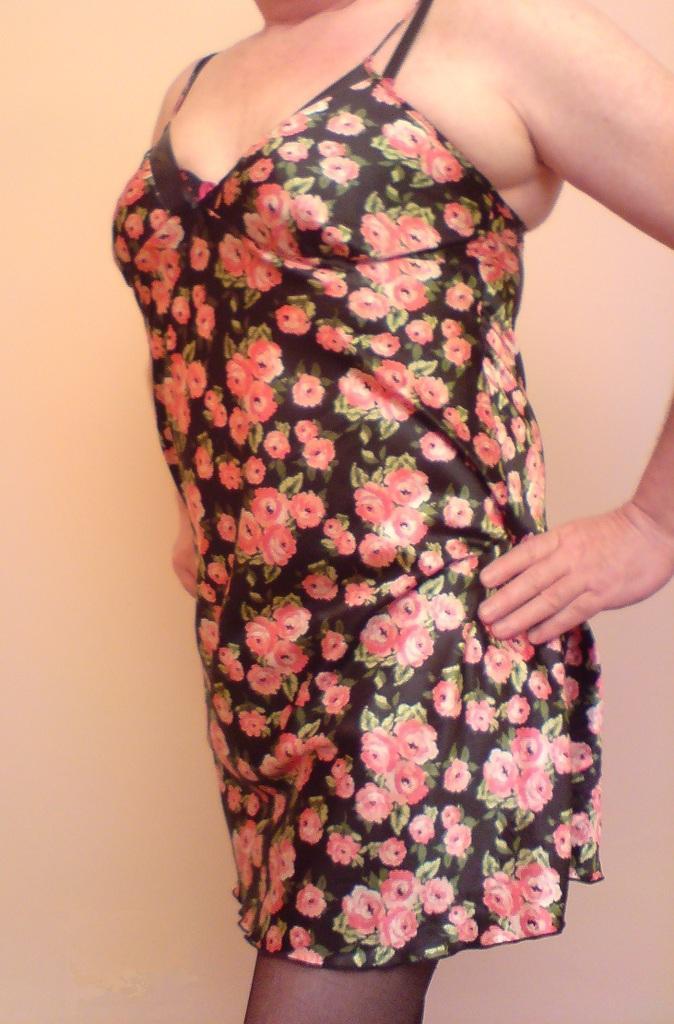Describe this image in one or two sentences. In this picture I can see a person and a plain background. 